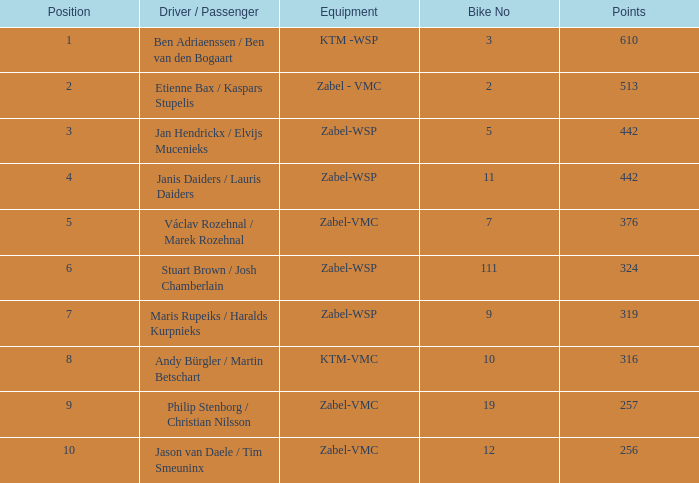Give me the full table as a dictionary. {'header': ['Position', 'Driver / Passenger', 'Equipment', 'Bike No', 'Points'], 'rows': [['1', 'Ben Adriaenssen / Ben van den Bogaart', 'KTM -WSP', '3', '610'], ['2', 'Etienne Bax / Kaspars Stupelis', 'Zabel - VMC', '2', '513'], ['3', 'Jan Hendrickx / Elvijs Mucenieks', 'Zabel-WSP', '5', '442'], ['4', 'Janis Daiders / Lauris Daiders', 'Zabel-WSP', '11', '442'], ['5', 'Václav Rozehnal / Marek Rozehnal', 'Zabel-VMC', '7', '376'], ['6', 'Stuart Brown / Josh Chamberlain', 'Zabel-WSP', '111', '324'], ['7', 'Maris Rupeiks / Haralds Kurpnieks', 'Zabel-WSP', '9', '319'], ['8', 'Andy Bürgler / Martin Betschart', 'KTM-VMC', '10', '316'], ['9', 'Philip Stenborg / Christian Nilsson', 'Zabel-VMC', '19', '257'], ['10', 'Jason van Daele / Tim Smeuninx', 'Zabel-VMC', '12', '256']]} What is the Equipment that has a Points littler than 442, and a Position of 9? Zabel-VMC. 